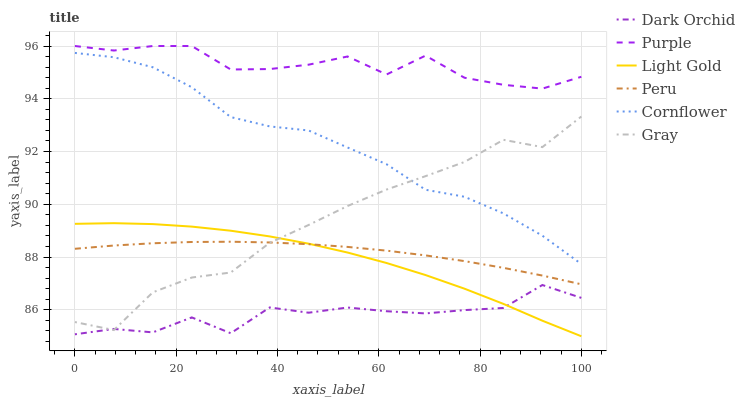Does Gray have the minimum area under the curve?
Answer yes or no. No. Does Gray have the maximum area under the curve?
Answer yes or no. No. Is Gray the smoothest?
Answer yes or no. No. Is Gray the roughest?
Answer yes or no. No. Does Gray have the lowest value?
Answer yes or no. No. Does Gray have the highest value?
Answer yes or no. No. Is Light Gold less than Purple?
Answer yes or no. Yes. Is Purple greater than Cornflower?
Answer yes or no. Yes. Does Light Gold intersect Purple?
Answer yes or no. No. 